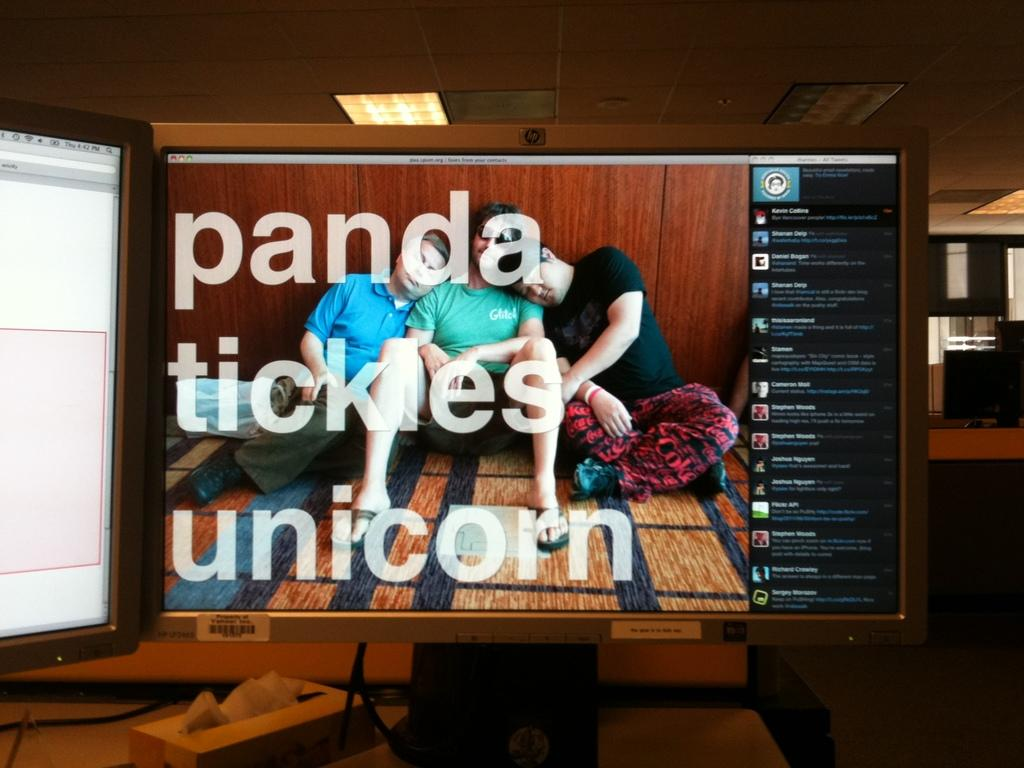<image>
Give a short and clear explanation of the subsequent image. a screen showing people and a caption saying panda tickles unicorn 